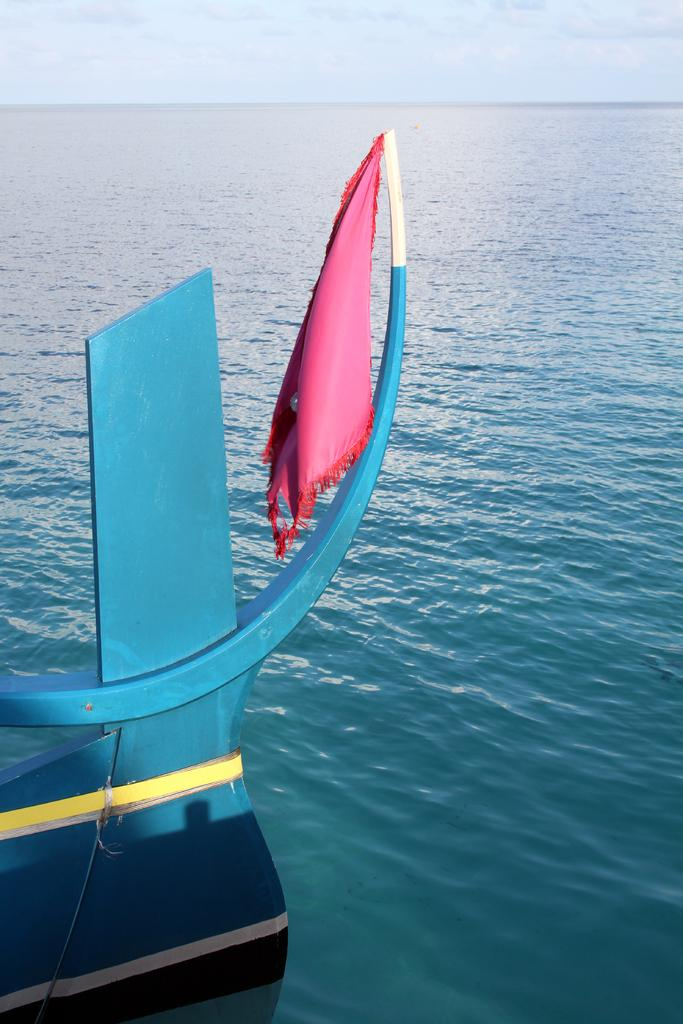What is the main subject of the image? The main subject of the image is a boat. Where is the boat located? The boat is on the water. What is present on the edge of the boat? There is a cloth on the edge of the boat. What can be seen in the background of the image? The sky is visible in the background of the image. What type of skirt is hanging from the boat in the image? There is no skirt present in the image; it is a cloth on the edge of the boat. 